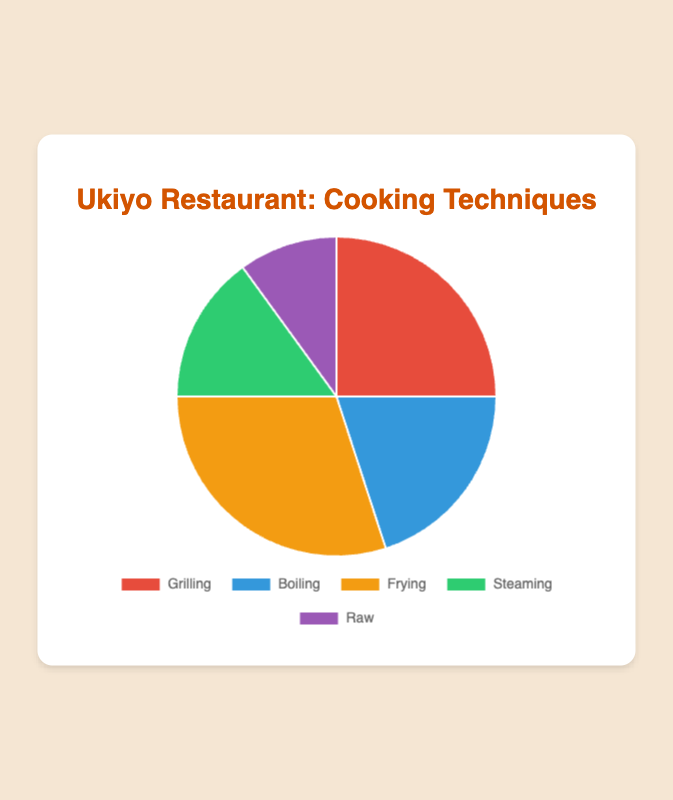What's the technique that is used the most? Frying is used the most as it has the largest proportion of 30% on the pie chart.
Answer: Frying Which technique has a smaller proportion than Boiling but a larger proportion than Raw? Steaming has a smaller proportion than Boiling (20%) but a larger proportion than Raw (10%). Steaming's proportion is 15%.
Answer: Steaming What is the combined proportion of Grilling and Frying? Add the proportions for Grilling (25%) and Frying (30%). 25% + 30% = 55%.
Answer: 55% Which technique's proportion is represented by the green section on the pie chart? The green section represents Steaming, as indicated by the color key on the chart.
Answer: Steaming How much larger is Frying compared to Raw in terms of proportion? Subtract Raw's proportion (10%) from Frying's proportion (30%). 30% - 10% = 20%.
Answer: 20% What is the average proportion of all the techniques? Add all the proportions: 25% + 20% + 30% + 15% + 10% = 100%. Then divide by the number of techniques (5). 100% / 5 = 20%.
Answer: 20% Which two techniques, when combined, have the same proportion as Frying? The combined proportion of Grilling (25%) and Steaming (15%) equals 40%, which is larger than 30% for Frying. Instead, Boiling (20%) and Steaming (15%) sum up to 35%, still larger. Using Grilling and Boiling, 25% + 20% = 45%, more than 30%. We check all combinations to find none equal exactly 30%.
Answer: None If the pie chart is divided into two equal halves, which technique proportions would be required to make one exact half? Frying alone is 30% and more than any single technique sum, joined with Boiling (20%) to result in 50%. Alternatively, create a list of combinations upon inspecting the chart to procure half box: Grilling, Steaming & Raw equates 25% + 15% + 10% summing up directly.
Answer: Grilling, Steaming, and Raw Which technique on the pie chart is closest in proportion to Boiling? Steaming at 15% and Frying at 30% mark closest proportions wielding the chart. Comparing distinct measures, Steaming is closer to Boiling's 20%.
Answer: Steaming 